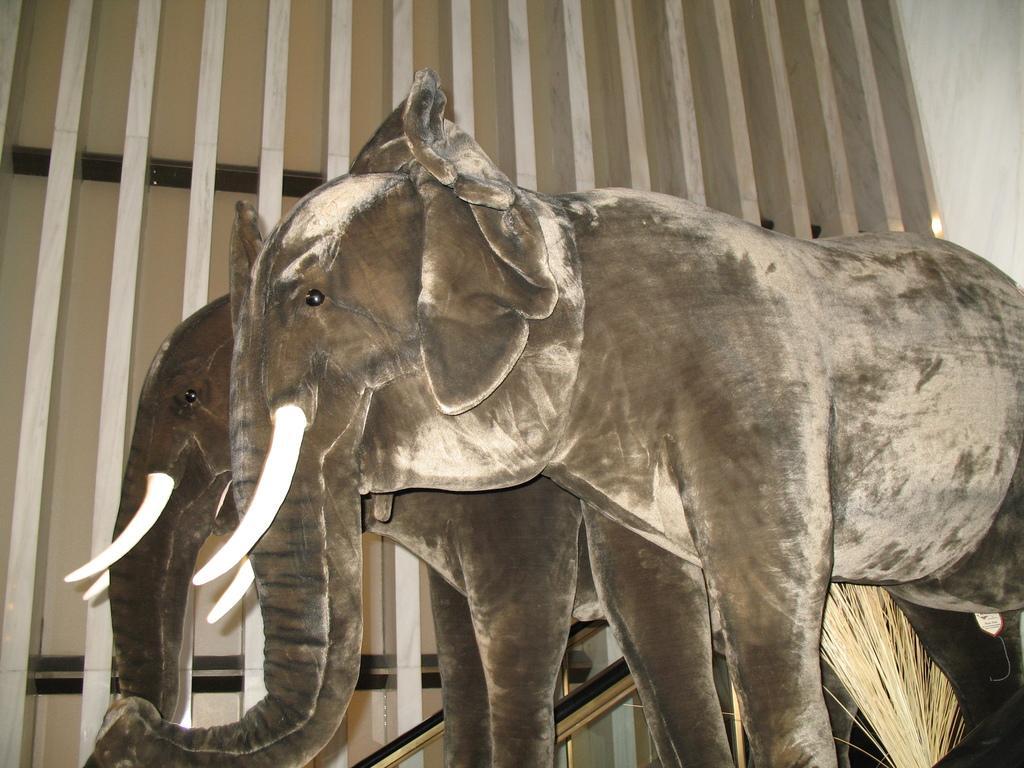How would you summarize this image in a sentence or two? In the image we can see there are cardboard sheets of elephants and behind there is wall. 